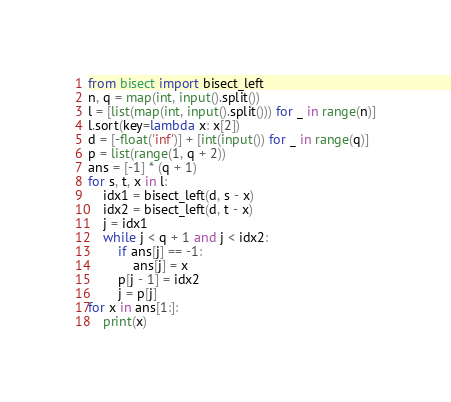Convert code to text. <code><loc_0><loc_0><loc_500><loc_500><_Python_>from bisect import bisect_left
n, q = map(int, input().split())
l = [list(map(int, input().split())) for _ in range(n)]
l.sort(key=lambda x: x[2])
d = [-float('inf')] + [int(input()) for _ in range(q)]
p = list(range(1, q + 2))
ans = [-1] * (q + 1)
for s, t, x in l:
    idx1 = bisect_left(d, s - x)
    idx2 = bisect_left(d, t - x)
    j = idx1
    while j < q + 1 and j < idx2:
        if ans[j] == -1:
            ans[j] = x
        p[j - 1] = idx2
        j = p[j]
for x in ans[1:]:
    print(x)
</code> 